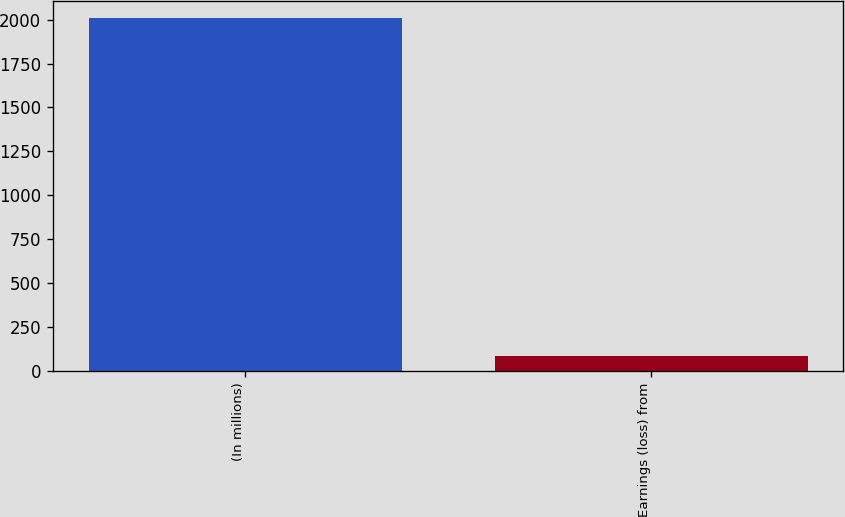Convert chart. <chart><loc_0><loc_0><loc_500><loc_500><bar_chart><fcel>(In millions)<fcel>Earnings (loss) from<nl><fcel>2009<fcel>82<nl></chart> 